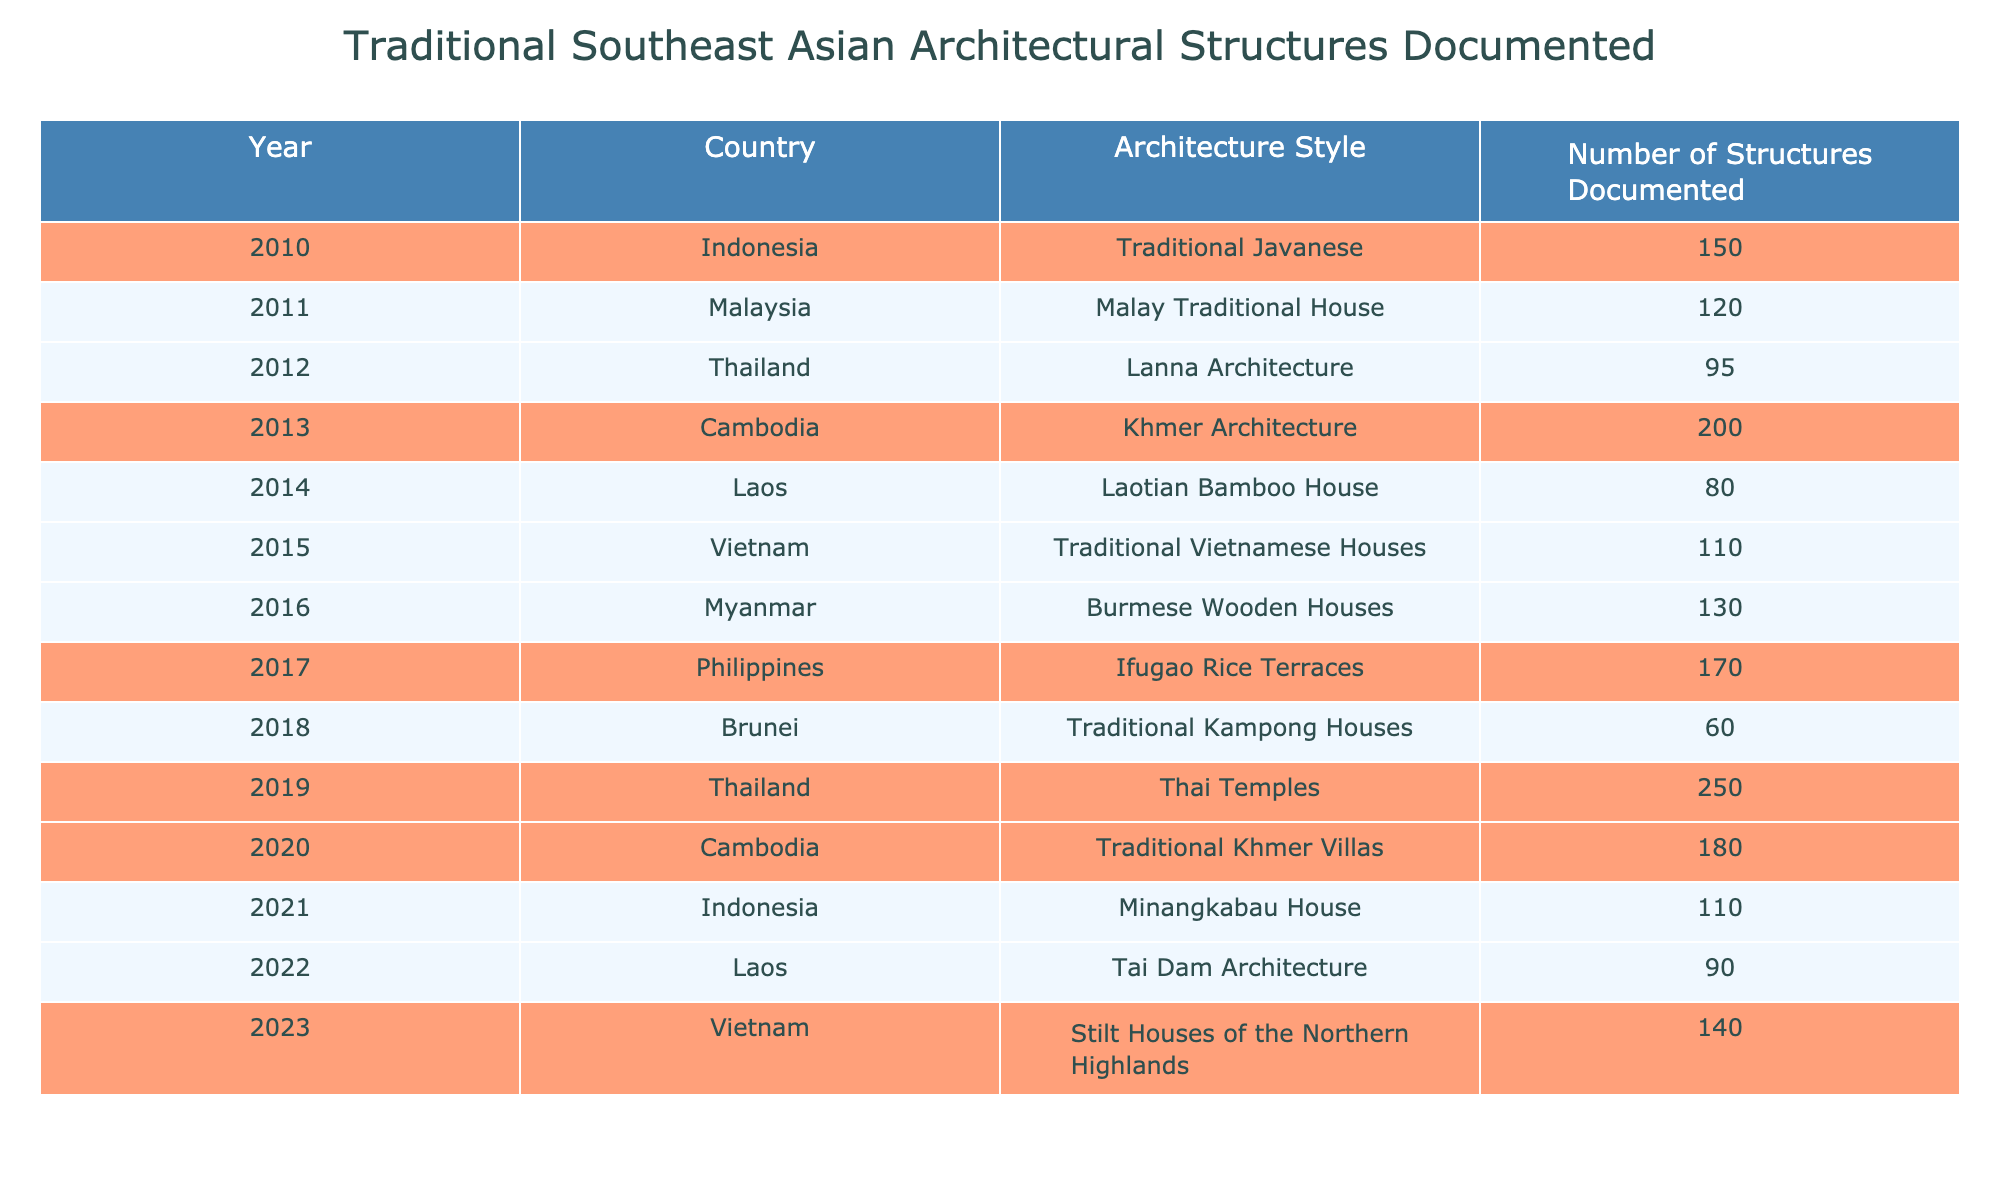What is the total number of structures documented in 2019? Referring to the table for the year 2019, it shows that 250 structures were documented in Thailand.
Answer: 250 Which country documented the highest number of traditional structures in a single year? By reviewing the table, the highest number is 250 in Thailand for the year 2019.
Answer: Thailand How many structures were documented in Cambodia in 2020? Looking at the table, Cambodia documented 180 structures in the year 2020.
Answer: 180 What style of architecture had the lowest number of structures documented? The table indicates that the Laotian Bamboo House style had the least, with only 80 structures documented in 2014.
Answer: Laotian Bamboo House What is the average number of structures documented across the years shown? Adding all the documented structures (150 + 120 + 95 + 200 + 80 + 110 + 130 + 170 + 60 + 250 + 180 + 110 + 90 + 140 = 1,590) and dividing by the 14 years gives an average of 113.57 structures.
Answer: 113.57 Which two years had the same number of structures documented? Checking the table reveals that 2011 and 2021 both documented 110 structures.
Answer: 2011 and 2021 Is the total number of structures documented in 2022 greater than the total for both 2014 and 2015 combined? The 2022 total is 90, while 2014 and 2015 combined have 80 + 110 = 190, which is greater than 90.
Answer: No What was the difference in the number of structures documented between the highest and the lowest in the table? The highest number is 250 (2019, Thailand) and the lowest is 60 (2018, Brunei). The difference is 250 - 60 = 190.
Answer: 190 In which year was the second highest number of structures documented? In the table, the second highest number of structures documented was 200 in Cambodia in 2013.
Answer: 2013 Did more structures get documented in Vietnam than in Laos across the years listed? Summing for Vietnam gives 110 (2015) + 140 (2023) = 250, and for Laos it gives 80 (2014) + 90 (2022) = 170, thus Vietnam has more.
Answer: Yes 